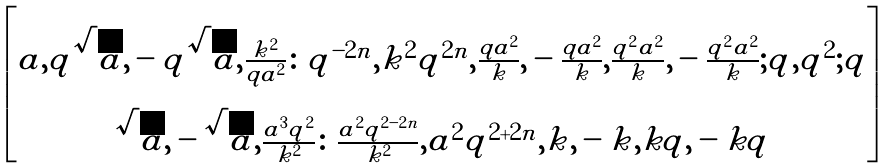Convert formula to latex. <formula><loc_0><loc_0><loc_500><loc_500>\begin{bmatrix} a , q \sqrt { a } , - q \sqrt { a } , \frac { k ^ { 2 } } { q a ^ { 2 } } \colon q ^ { - 2 n } , k ^ { 2 } q ^ { 2 n } , \frac { q a ^ { 2 } } { k } , - \frac { q a ^ { 2 } } { k } , \frac { q ^ { 2 } a ^ { 2 } } { k } , - \frac { q ^ { 2 } a ^ { 2 } } { k } ; q , q ^ { 2 } ; q \\ \sqrt { a } , - \sqrt { a } , \frac { a ^ { 3 } q ^ { 2 } } { k ^ { 2 } } \colon \frac { a ^ { 2 } q ^ { 2 - 2 n } } { k ^ { 2 } } , a ^ { 2 } q ^ { 2 + 2 n } , k , - k , k q , - k q \end{bmatrix}</formula> 